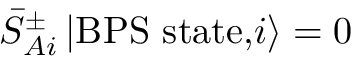<formula> <loc_0><loc_0><loc_500><loc_500>{ \bar { S } } _ { A i } ^ { \pm } \, | B P S s t a t e , i \rangle = 0</formula> 